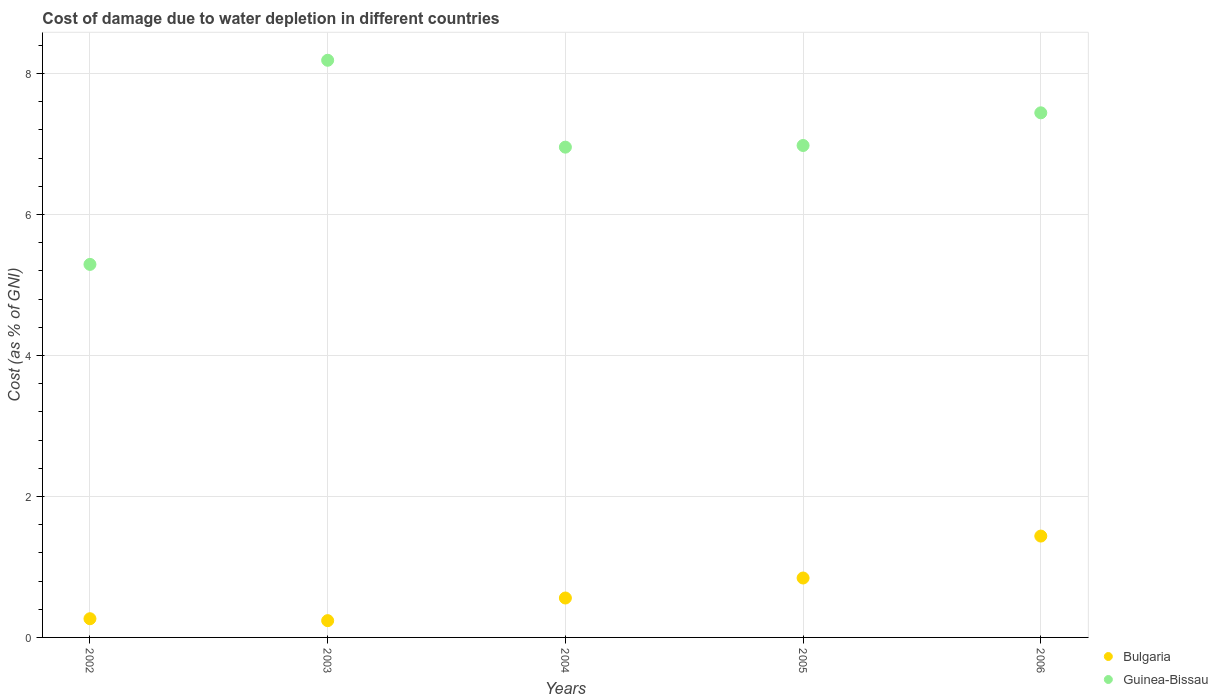Is the number of dotlines equal to the number of legend labels?
Give a very brief answer. Yes. What is the cost of damage caused due to water depletion in Bulgaria in 2005?
Keep it short and to the point. 0.84. Across all years, what is the maximum cost of damage caused due to water depletion in Bulgaria?
Offer a very short reply. 1.44. Across all years, what is the minimum cost of damage caused due to water depletion in Bulgaria?
Make the answer very short. 0.24. In which year was the cost of damage caused due to water depletion in Guinea-Bissau minimum?
Provide a succinct answer. 2002. What is the total cost of damage caused due to water depletion in Bulgaria in the graph?
Provide a succinct answer. 3.34. What is the difference between the cost of damage caused due to water depletion in Bulgaria in 2002 and that in 2004?
Your response must be concise. -0.29. What is the difference between the cost of damage caused due to water depletion in Guinea-Bissau in 2003 and the cost of damage caused due to water depletion in Bulgaria in 2005?
Give a very brief answer. 7.35. What is the average cost of damage caused due to water depletion in Bulgaria per year?
Offer a very short reply. 0.67. In the year 2005, what is the difference between the cost of damage caused due to water depletion in Guinea-Bissau and cost of damage caused due to water depletion in Bulgaria?
Your answer should be compact. 6.14. In how many years, is the cost of damage caused due to water depletion in Guinea-Bissau greater than 5.2 %?
Provide a succinct answer. 5. What is the ratio of the cost of damage caused due to water depletion in Bulgaria in 2003 to that in 2004?
Provide a short and direct response. 0.43. Is the difference between the cost of damage caused due to water depletion in Guinea-Bissau in 2003 and 2006 greater than the difference between the cost of damage caused due to water depletion in Bulgaria in 2003 and 2006?
Your answer should be compact. Yes. What is the difference between the highest and the second highest cost of damage caused due to water depletion in Bulgaria?
Provide a succinct answer. 0.59. What is the difference between the highest and the lowest cost of damage caused due to water depletion in Bulgaria?
Give a very brief answer. 1.2. In how many years, is the cost of damage caused due to water depletion in Bulgaria greater than the average cost of damage caused due to water depletion in Bulgaria taken over all years?
Keep it short and to the point. 2. Is the sum of the cost of damage caused due to water depletion in Guinea-Bissau in 2005 and 2006 greater than the maximum cost of damage caused due to water depletion in Bulgaria across all years?
Provide a short and direct response. Yes. Is the cost of damage caused due to water depletion in Bulgaria strictly greater than the cost of damage caused due to water depletion in Guinea-Bissau over the years?
Ensure brevity in your answer.  No. Is the cost of damage caused due to water depletion in Bulgaria strictly less than the cost of damage caused due to water depletion in Guinea-Bissau over the years?
Give a very brief answer. Yes. What is the difference between two consecutive major ticks on the Y-axis?
Provide a succinct answer. 2. Are the values on the major ticks of Y-axis written in scientific E-notation?
Your answer should be very brief. No. Does the graph contain any zero values?
Give a very brief answer. No. Does the graph contain grids?
Provide a short and direct response. Yes. What is the title of the graph?
Your response must be concise. Cost of damage due to water depletion in different countries. Does "Colombia" appear as one of the legend labels in the graph?
Offer a very short reply. No. What is the label or title of the Y-axis?
Offer a terse response. Cost (as % of GNI). What is the Cost (as % of GNI) in Bulgaria in 2002?
Your response must be concise. 0.27. What is the Cost (as % of GNI) of Guinea-Bissau in 2002?
Make the answer very short. 5.29. What is the Cost (as % of GNI) of Bulgaria in 2003?
Your answer should be compact. 0.24. What is the Cost (as % of GNI) in Guinea-Bissau in 2003?
Keep it short and to the point. 8.19. What is the Cost (as % of GNI) of Bulgaria in 2004?
Offer a terse response. 0.56. What is the Cost (as % of GNI) of Guinea-Bissau in 2004?
Make the answer very short. 6.96. What is the Cost (as % of GNI) in Bulgaria in 2005?
Give a very brief answer. 0.84. What is the Cost (as % of GNI) of Guinea-Bissau in 2005?
Ensure brevity in your answer.  6.98. What is the Cost (as % of GNI) of Bulgaria in 2006?
Provide a succinct answer. 1.44. What is the Cost (as % of GNI) of Guinea-Bissau in 2006?
Make the answer very short. 7.44. Across all years, what is the maximum Cost (as % of GNI) of Bulgaria?
Make the answer very short. 1.44. Across all years, what is the maximum Cost (as % of GNI) in Guinea-Bissau?
Offer a terse response. 8.19. Across all years, what is the minimum Cost (as % of GNI) of Bulgaria?
Make the answer very short. 0.24. Across all years, what is the minimum Cost (as % of GNI) in Guinea-Bissau?
Offer a very short reply. 5.29. What is the total Cost (as % of GNI) of Bulgaria in the graph?
Make the answer very short. 3.34. What is the total Cost (as % of GNI) in Guinea-Bissau in the graph?
Offer a very short reply. 34.86. What is the difference between the Cost (as % of GNI) of Bulgaria in 2002 and that in 2003?
Ensure brevity in your answer.  0.03. What is the difference between the Cost (as % of GNI) of Guinea-Bissau in 2002 and that in 2003?
Provide a short and direct response. -2.9. What is the difference between the Cost (as % of GNI) of Bulgaria in 2002 and that in 2004?
Your answer should be compact. -0.29. What is the difference between the Cost (as % of GNI) of Guinea-Bissau in 2002 and that in 2004?
Your response must be concise. -1.66. What is the difference between the Cost (as % of GNI) in Bulgaria in 2002 and that in 2005?
Your answer should be compact. -0.58. What is the difference between the Cost (as % of GNI) in Guinea-Bissau in 2002 and that in 2005?
Keep it short and to the point. -1.69. What is the difference between the Cost (as % of GNI) in Bulgaria in 2002 and that in 2006?
Give a very brief answer. -1.17. What is the difference between the Cost (as % of GNI) of Guinea-Bissau in 2002 and that in 2006?
Offer a very short reply. -2.15. What is the difference between the Cost (as % of GNI) of Bulgaria in 2003 and that in 2004?
Your answer should be very brief. -0.32. What is the difference between the Cost (as % of GNI) of Guinea-Bissau in 2003 and that in 2004?
Make the answer very short. 1.23. What is the difference between the Cost (as % of GNI) of Bulgaria in 2003 and that in 2005?
Provide a short and direct response. -0.6. What is the difference between the Cost (as % of GNI) in Guinea-Bissau in 2003 and that in 2005?
Make the answer very short. 1.21. What is the difference between the Cost (as % of GNI) in Bulgaria in 2003 and that in 2006?
Offer a very short reply. -1.2. What is the difference between the Cost (as % of GNI) in Guinea-Bissau in 2003 and that in 2006?
Ensure brevity in your answer.  0.75. What is the difference between the Cost (as % of GNI) in Bulgaria in 2004 and that in 2005?
Offer a terse response. -0.28. What is the difference between the Cost (as % of GNI) of Guinea-Bissau in 2004 and that in 2005?
Provide a short and direct response. -0.02. What is the difference between the Cost (as % of GNI) of Bulgaria in 2004 and that in 2006?
Provide a succinct answer. -0.88. What is the difference between the Cost (as % of GNI) of Guinea-Bissau in 2004 and that in 2006?
Make the answer very short. -0.49. What is the difference between the Cost (as % of GNI) of Bulgaria in 2005 and that in 2006?
Your response must be concise. -0.59. What is the difference between the Cost (as % of GNI) of Guinea-Bissau in 2005 and that in 2006?
Offer a terse response. -0.46. What is the difference between the Cost (as % of GNI) of Bulgaria in 2002 and the Cost (as % of GNI) of Guinea-Bissau in 2003?
Make the answer very short. -7.92. What is the difference between the Cost (as % of GNI) of Bulgaria in 2002 and the Cost (as % of GNI) of Guinea-Bissau in 2004?
Give a very brief answer. -6.69. What is the difference between the Cost (as % of GNI) in Bulgaria in 2002 and the Cost (as % of GNI) in Guinea-Bissau in 2005?
Ensure brevity in your answer.  -6.71. What is the difference between the Cost (as % of GNI) in Bulgaria in 2002 and the Cost (as % of GNI) in Guinea-Bissau in 2006?
Ensure brevity in your answer.  -7.18. What is the difference between the Cost (as % of GNI) of Bulgaria in 2003 and the Cost (as % of GNI) of Guinea-Bissau in 2004?
Ensure brevity in your answer.  -6.72. What is the difference between the Cost (as % of GNI) in Bulgaria in 2003 and the Cost (as % of GNI) in Guinea-Bissau in 2005?
Your answer should be compact. -6.74. What is the difference between the Cost (as % of GNI) in Bulgaria in 2003 and the Cost (as % of GNI) in Guinea-Bissau in 2006?
Your answer should be compact. -7.2. What is the difference between the Cost (as % of GNI) of Bulgaria in 2004 and the Cost (as % of GNI) of Guinea-Bissau in 2005?
Your answer should be compact. -6.42. What is the difference between the Cost (as % of GNI) in Bulgaria in 2004 and the Cost (as % of GNI) in Guinea-Bissau in 2006?
Your answer should be compact. -6.88. What is the difference between the Cost (as % of GNI) in Bulgaria in 2005 and the Cost (as % of GNI) in Guinea-Bissau in 2006?
Your answer should be compact. -6.6. What is the average Cost (as % of GNI) in Bulgaria per year?
Your response must be concise. 0.67. What is the average Cost (as % of GNI) of Guinea-Bissau per year?
Ensure brevity in your answer.  6.97. In the year 2002, what is the difference between the Cost (as % of GNI) of Bulgaria and Cost (as % of GNI) of Guinea-Bissau?
Keep it short and to the point. -5.03. In the year 2003, what is the difference between the Cost (as % of GNI) in Bulgaria and Cost (as % of GNI) in Guinea-Bissau?
Your answer should be very brief. -7.95. In the year 2004, what is the difference between the Cost (as % of GNI) of Bulgaria and Cost (as % of GNI) of Guinea-Bissau?
Offer a terse response. -6.4. In the year 2005, what is the difference between the Cost (as % of GNI) in Bulgaria and Cost (as % of GNI) in Guinea-Bissau?
Give a very brief answer. -6.14. In the year 2006, what is the difference between the Cost (as % of GNI) in Bulgaria and Cost (as % of GNI) in Guinea-Bissau?
Provide a short and direct response. -6. What is the ratio of the Cost (as % of GNI) in Bulgaria in 2002 to that in 2003?
Provide a short and direct response. 1.11. What is the ratio of the Cost (as % of GNI) of Guinea-Bissau in 2002 to that in 2003?
Make the answer very short. 0.65. What is the ratio of the Cost (as % of GNI) in Bulgaria in 2002 to that in 2004?
Make the answer very short. 0.47. What is the ratio of the Cost (as % of GNI) of Guinea-Bissau in 2002 to that in 2004?
Give a very brief answer. 0.76. What is the ratio of the Cost (as % of GNI) of Bulgaria in 2002 to that in 2005?
Offer a terse response. 0.31. What is the ratio of the Cost (as % of GNI) in Guinea-Bissau in 2002 to that in 2005?
Your response must be concise. 0.76. What is the ratio of the Cost (as % of GNI) in Bulgaria in 2002 to that in 2006?
Ensure brevity in your answer.  0.18. What is the ratio of the Cost (as % of GNI) in Guinea-Bissau in 2002 to that in 2006?
Your answer should be compact. 0.71. What is the ratio of the Cost (as % of GNI) in Bulgaria in 2003 to that in 2004?
Give a very brief answer. 0.43. What is the ratio of the Cost (as % of GNI) in Guinea-Bissau in 2003 to that in 2004?
Your response must be concise. 1.18. What is the ratio of the Cost (as % of GNI) in Bulgaria in 2003 to that in 2005?
Offer a very short reply. 0.28. What is the ratio of the Cost (as % of GNI) in Guinea-Bissau in 2003 to that in 2005?
Give a very brief answer. 1.17. What is the ratio of the Cost (as % of GNI) of Bulgaria in 2003 to that in 2006?
Provide a succinct answer. 0.17. What is the ratio of the Cost (as % of GNI) in Guinea-Bissau in 2003 to that in 2006?
Provide a short and direct response. 1.1. What is the ratio of the Cost (as % of GNI) in Bulgaria in 2004 to that in 2005?
Offer a very short reply. 0.66. What is the ratio of the Cost (as % of GNI) of Bulgaria in 2004 to that in 2006?
Offer a very short reply. 0.39. What is the ratio of the Cost (as % of GNI) in Guinea-Bissau in 2004 to that in 2006?
Provide a short and direct response. 0.93. What is the ratio of the Cost (as % of GNI) of Bulgaria in 2005 to that in 2006?
Offer a terse response. 0.59. What is the ratio of the Cost (as % of GNI) in Guinea-Bissau in 2005 to that in 2006?
Provide a short and direct response. 0.94. What is the difference between the highest and the second highest Cost (as % of GNI) of Bulgaria?
Keep it short and to the point. 0.59. What is the difference between the highest and the second highest Cost (as % of GNI) in Guinea-Bissau?
Offer a very short reply. 0.75. What is the difference between the highest and the lowest Cost (as % of GNI) in Guinea-Bissau?
Make the answer very short. 2.9. 